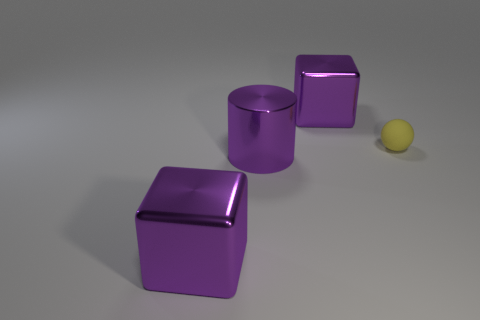Add 3 large purple metallic objects. How many objects exist? 7 Subtract all balls. How many objects are left? 3 Subtract all large shiny objects. Subtract all small red rubber things. How many objects are left? 1 Add 4 purple metallic cubes. How many purple metallic cubes are left? 6 Add 3 big objects. How many big objects exist? 6 Subtract 0 red cubes. How many objects are left? 4 